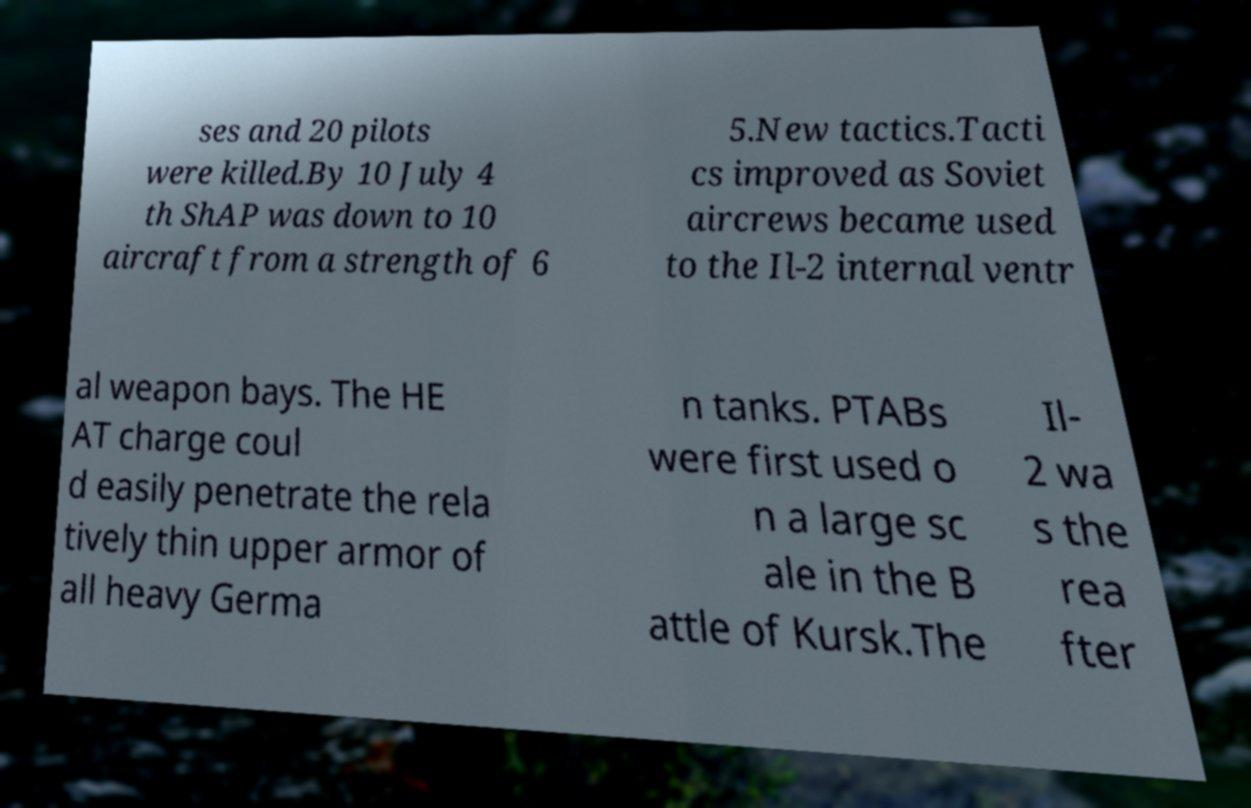Please read and relay the text visible in this image. What does it say? ses and 20 pilots were killed.By 10 July 4 th ShAP was down to 10 aircraft from a strength of 6 5.New tactics.Tacti cs improved as Soviet aircrews became used to the Il-2 internal ventr al weapon bays. The HE AT charge coul d easily penetrate the rela tively thin upper armor of all heavy Germa n tanks. PTABs were first used o n a large sc ale in the B attle of Kursk.The Il- 2 wa s the rea fter 